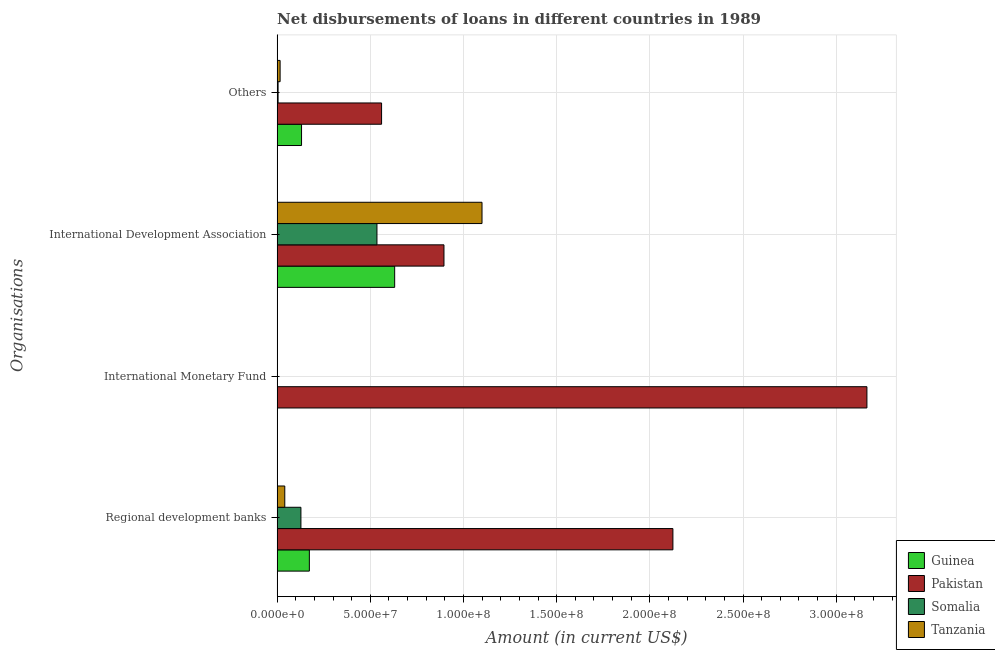How many bars are there on the 2nd tick from the top?
Offer a very short reply. 4. What is the label of the 2nd group of bars from the top?
Provide a short and direct response. International Development Association. What is the amount of loan disimbursed by regional development banks in Pakistan?
Your answer should be very brief. 2.12e+08. Across all countries, what is the maximum amount of loan disimbursed by regional development banks?
Give a very brief answer. 2.12e+08. Across all countries, what is the minimum amount of loan disimbursed by international development association?
Provide a short and direct response. 5.36e+07. In which country was the amount of loan disimbursed by regional development banks maximum?
Offer a very short reply. Pakistan. What is the total amount of loan disimbursed by international development association in the graph?
Make the answer very short. 3.16e+08. What is the difference between the amount of loan disimbursed by international development association in Guinea and that in Pakistan?
Your response must be concise. -2.65e+07. What is the difference between the amount of loan disimbursed by regional development banks in Guinea and the amount of loan disimbursed by international monetary fund in Somalia?
Provide a succinct answer. 1.73e+07. What is the average amount of loan disimbursed by other organisations per country?
Provide a succinct answer. 1.78e+07. What is the difference between the amount of loan disimbursed by regional development banks and amount of loan disimbursed by other organisations in Pakistan?
Offer a terse response. 1.56e+08. In how many countries, is the amount of loan disimbursed by international monetary fund greater than 230000000 US$?
Give a very brief answer. 1. What is the ratio of the amount of loan disimbursed by regional development banks in Tanzania to that in Somalia?
Ensure brevity in your answer.  0.32. Is the amount of loan disimbursed by regional development banks in Somalia less than that in Guinea?
Offer a very short reply. Yes. What is the difference between the highest and the lowest amount of loan disimbursed by regional development banks?
Offer a terse response. 2.08e+08. Is it the case that in every country, the sum of the amount of loan disimbursed by international monetary fund and amount of loan disimbursed by other organisations is greater than the sum of amount of loan disimbursed by international development association and amount of loan disimbursed by regional development banks?
Give a very brief answer. No. How many bars are there?
Your response must be concise. 13. Are all the bars in the graph horizontal?
Your answer should be compact. Yes. How many countries are there in the graph?
Give a very brief answer. 4. Does the graph contain grids?
Your answer should be compact. Yes. Where does the legend appear in the graph?
Provide a succinct answer. Bottom right. What is the title of the graph?
Your answer should be compact. Net disbursements of loans in different countries in 1989. What is the label or title of the Y-axis?
Your answer should be compact. Organisations. What is the Amount (in current US$) of Guinea in Regional development banks?
Make the answer very short. 1.73e+07. What is the Amount (in current US$) of Pakistan in Regional development banks?
Your answer should be very brief. 2.12e+08. What is the Amount (in current US$) of Somalia in Regional development banks?
Your response must be concise. 1.28e+07. What is the Amount (in current US$) in Tanzania in Regional development banks?
Your response must be concise. 4.11e+06. What is the Amount (in current US$) of Pakistan in International Monetary Fund?
Ensure brevity in your answer.  3.16e+08. What is the Amount (in current US$) of Tanzania in International Monetary Fund?
Your answer should be very brief. 0. What is the Amount (in current US$) of Guinea in International Development Association?
Your answer should be very brief. 6.31e+07. What is the Amount (in current US$) in Pakistan in International Development Association?
Your response must be concise. 8.95e+07. What is the Amount (in current US$) of Somalia in International Development Association?
Make the answer very short. 5.36e+07. What is the Amount (in current US$) in Tanzania in International Development Association?
Your response must be concise. 1.10e+08. What is the Amount (in current US$) of Guinea in Others?
Keep it short and to the point. 1.31e+07. What is the Amount (in current US$) of Pakistan in Others?
Provide a short and direct response. 5.60e+07. What is the Amount (in current US$) of Somalia in Others?
Offer a very short reply. 5.13e+05. What is the Amount (in current US$) in Tanzania in Others?
Your response must be concise. 1.60e+06. Across all Organisations, what is the maximum Amount (in current US$) in Guinea?
Provide a succinct answer. 6.31e+07. Across all Organisations, what is the maximum Amount (in current US$) of Pakistan?
Your answer should be very brief. 3.16e+08. Across all Organisations, what is the maximum Amount (in current US$) in Somalia?
Offer a very short reply. 5.36e+07. Across all Organisations, what is the maximum Amount (in current US$) of Tanzania?
Provide a short and direct response. 1.10e+08. Across all Organisations, what is the minimum Amount (in current US$) of Guinea?
Offer a terse response. 0. Across all Organisations, what is the minimum Amount (in current US$) of Pakistan?
Your answer should be compact. 5.60e+07. What is the total Amount (in current US$) in Guinea in the graph?
Give a very brief answer. 9.35e+07. What is the total Amount (in current US$) of Pakistan in the graph?
Provide a short and direct response. 6.74e+08. What is the total Amount (in current US$) of Somalia in the graph?
Provide a succinct answer. 6.68e+07. What is the total Amount (in current US$) in Tanzania in the graph?
Make the answer very short. 1.16e+08. What is the difference between the Amount (in current US$) in Pakistan in Regional development banks and that in International Monetary Fund?
Make the answer very short. -1.04e+08. What is the difference between the Amount (in current US$) in Guinea in Regional development banks and that in International Development Association?
Your answer should be very brief. -4.58e+07. What is the difference between the Amount (in current US$) of Pakistan in Regional development banks and that in International Development Association?
Give a very brief answer. 1.23e+08. What is the difference between the Amount (in current US$) in Somalia in Regional development banks and that in International Development Association?
Provide a short and direct response. -4.08e+07. What is the difference between the Amount (in current US$) in Tanzania in Regional development banks and that in International Development Association?
Your answer should be very brief. -1.06e+08. What is the difference between the Amount (in current US$) in Guinea in Regional development banks and that in Others?
Keep it short and to the point. 4.19e+06. What is the difference between the Amount (in current US$) in Pakistan in Regional development banks and that in Others?
Provide a short and direct response. 1.56e+08. What is the difference between the Amount (in current US$) in Somalia in Regional development banks and that in Others?
Ensure brevity in your answer.  1.23e+07. What is the difference between the Amount (in current US$) of Tanzania in Regional development banks and that in Others?
Your answer should be very brief. 2.51e+06. What is the difference between the Amount (in current US$) in Pakistan in International Monetary Fund and that in International Development Association?
Make the answer very short. 2.27e+08. What is the difference between the Amount (in current US$) of Pakistan in International Monetary Fund and that in Others?
Ensure brevity in your answer.  2.60e+08. What is the difference between the Amount (in current US$) of Guinea in International Development Association and that in Others?
Your answer should be very brief. 5.00e+07. What is the difference between the Amount (in current US$) in Pakistan in International Development Association and that in Others?
Offer a terse response. 3.35e+07. What is the difference between the Amount (in current US$) in Somalia in International Development Association and that in Others?
Your answer should be compact. 5.31e+07. What is the difference between the Amount (in current US$) in Tanzania in International Development Association and that in Others?
Your answer should be very brief. 1.08e+08. What is the difference between the Amount (in current US$) of Guinea in Regional development banks and the Amount (in current US$) of Pakistan in International Monetary Fund?
Keep it short and to the point. -2.99e+08. What is the difference between the Amount (in current US$) in Guinea in Regional development banks and the Amount (in current US$) in Pakistan in International Development Association?
Provide a succinct answer. -7.22e+07. What is the difference between the Amount (in current US$) of Guinea in Regional development banks and the Amount (in current US$) of Somalia in International Development Association?
Ensure brevity in your answer.  -3.63e+07. What is the difference between the Amount (in current US$) of Guinea in Regional development banks and the Amount (in current US$) of Tanzania in International Development Association?
Make the answer very short. -9.26e+07. What is the difference between the Amount (in current US$) in Pakistan in Regional development banks and the Amount (in current US$) in Somalia in International Development Association?
Offer a very short reply. 1.59e+08. What is the difference between the Amount (in current US$) in Pakistan in Regional development banks and the Amount (in current US$) in Tanzania in International Development Association?
Ensure brevity in your answer.  1.02e+08. What is the difference between the Amount (in current US$) of Somalia in Regional development banks and the Amount (in current US$) of Tanzania in International Development Association?
Offer a terse response. -9.72e+07. What is the difference between the Amount (in current US$) in Guinea in Regional development banks and the Amount (in current US$) in Pakistan in Others?
Offer a terse response. -3.88e+07. What is the difference between the Amount (in current US$) in Guinea in Regional development banks and the Amount (in current US$) in Somalia in Others?
Offer a terse response. 1.68e+07. What is the difference between the Amount (in current US$) in Guinea in Regional development banks and the Amount (in current US$) in Tanzania in Others?
Your answer should be very brief. 1.57e+07. What is the difference between the Amount (in current US$) of Pakistan in Regional development banks and the Amount (in current US$) of Somalia in Others?
Your answer should be very brief. 2.12e+08. What is the difference between the Amount (in current US$) in Pakistan in Regional development banks and the Amount (in current US$) in Tanzania in Others?
Offer a terse response. 2.11e+08. What is the difference between the Amount (in current US$) of Somalia in Regional development banks and the Amount (in current US$) of Tanzania in Others?
Give a very brief answer. 1.12e+07. What is the difference between the Amount (in current US$) in Pakistan in International Monetary Fund and the Amount (in current US$) in Somalia in International Development Association?
Your response must be concise. 2.63e+08. What is the difference between the Amount (in current US$) in Pakistan in International Monetary Fund and the Amount (in current US$) in Tanzania in International Development Association?
Keep it short and to the point. 2.07e+08. What is the difference between the Amount (in current US$) of Pakistan in International Monetary Fund and the Amount (in current US$) of Somalia in Others?
Offer a very short reply. 3.16e+08. What is the difference between the Amount (in current US$) of Pakistan in International Monetary Fund and the Amount (in current US$) of Tanzania in Others?
Make the answer very short. 3.15e+08. What is the difference between the Amount (in current US$) in Guinea in International Development Association and the Amount (in current US$) in Pakistan in Others?
Offer a terse response. 7.02e+06. What is the difference between the Amount (in current US$) of Guinea in International Development Association and the Amount (in current US$) of Somalia in Others?
Ensure brevity in your answer.  6.26e+07. What is the difference between the Amount (in current US$) in Guinea in International Development Association and the Amount (in current US$) in Tanzania in Others?
Ensure brevity in your answer.  6.15e+07. What is the difference between the Amount (in current US$) of Pakistan in International Development Association and the Amount (in current US$) of Somalia in Others?
Provide a succinct answer. 8.90e+07. What is the difference between the Amount (in current US$) of Pakistan in International Development Association and the Amount (in current US$) of Tanzania in Others?
Your answer should be compact. 8.79e+07. What is the difference between the Amount (in current US$) in Somalia in International Development Association and the Amount (in current US$) in Tanzania in Others?
Your answer should be very brief. 5.20e+07. What is the average Amount (in current US$) of Guinea per Organisations?
Keep it short and to the point. 2.34e+07. What is the average Amount (in current US$) of Pakistan per Organisations?
Your answer should be compact. 1.69e+08. What is the average Amount (in current US$) of Somalia per Organisations?
Provide a succinct answer. 1.67e+07. What is the average Amount (in current US$) of Tanzania per Organisations?
Provide a short and direct response. 2.89e+07. What is the difference between the Amount (in current US$) in Guinea and Amount (in current US$) in Pakistan in Regional development banks?
Your answer should be very brief. -1.95e+08. What is the difference between the Amount (in current US$) of Guinea and Amount (in current US$) of Somalia in Regional development banks?
Your answer should be compact. 4.52e+06. What is the difference between the Amount (in current US$) of Guinea and Amount (in current US$) of Tanzania in Regional development banks?
Your answer should be compact. 1.32e+07. What is the difference between the Amount (in current US$) in Pakistan and Amount (in current US$) in Somalia in Regional development banks?
Keep it short and to the point. 2.00e+08. What is the difference between the Amount (in current US$) in Pakistan and Amount (in current US$) in Tanzania in Regional development banks?
Offer a very short reply. 2.08e+08. What is the difference between the Amount (in current US$) of Somalia and Amount (in current US$) of Tanzania in Regional development banks?
Give a very brief answer. 8.66e+06. What is the difference between the Amount (in current US$) of Guinea and Amount (in current US$) of Pakistan in International Development Association?
Make the answer very short. -2.65e+07. What is the difference between the Amount (in current US$) of Guinea and Amount (in current US$) of Somalia in International Development Association?
Your answer should be compact. 9.51e+06. What is the difference between the Amount (in current US$) of Guinea and Amount (in current US$) of Tanzania in International Development Association?
Offer a terse response. -4.69e+07. What is the difference between the Amount (in current US$) of Pakistan and Amount (in current US$) of Somalia in International Development Association?
Make the answer very short. 3.60e+07. What is the difference between the Amount (in current US$) of Pakistan and Amount (in current US$) of Tanzania in International Development Association?
Your response must be concise. -2.04e+07. What is the difference between the Amount (in current US$) in Somalia and Amount (in current US$) in Tanzania in International Development Association?
Your answer should be very brief. -5.64e+07. What is the difference between the Amount (in current US$) of Guinea and Amount (in current US$) of Pakistan in Others?
Your response must be concise. -4.29e+07. What is the difference between the Amount (in current US$) in Guinea and Amount (in current US$) in Somalia in Others?
Provide a succinct answer. 1.26e+07. What is the difference between the Amount (in current US$) in Guinea and Amount (in current US$) in Tanzania in Others?
Your answer should be very brief. 1.15e+07. What is the difference between the Amount (in current US$) in Pakistan and Amount (in current US$) in Somalia in Others?
Provide a succinct answer. 5.55e+07. What is the difference between the Amount (in current US$) of Pakistan and Amount (in current US$) of Tanzania in Others?
Ensure brevity in your answer.  5.44e+07. What is the difference between the Amount (in current US$) in Somalia and Amount (in current US$) in Tanzania in Others?
Your answer should be compact. -1.09e+06. What is the ratio of the Amount (in current US$) in Pakistan in Regional development banks to that in International Monetary Fund?
Give a very brief answer. 0.67. What is the ratio of the Amount (in current US$) in Guinea in Regional development banks to that in International Development Association?
Offer a very short reply. 0.27. What is the ratio of the Amount (in current US$) of Pakistan in Regional development banks to that in International Development Association?
Offer a very short reply. 2.37. What is the ratio of the Amount (in current US$) in Somalia in Regional development banks to that in International Development Association?
Give a very brief answer. 0.24. What is the ratio of the Amount (in current US$) of Tanzania in Regional development banks to that in International Development Association?
Your answer should be compact. 0.04. What is the ratio of the Amount (in current US$) of Guinea in Regional development banks to that in Others?
Your answer should be very brief. 1.32. What is the ratio of the Amount (in current US$) of Pakistan in Regional development banks to that in Others?
Your answer should be compact. 3.79. What is the ratio of the Amount (in current US$) in Somalia in Regional development banks to that in Others?
Offer a terse response. 24.89. What is the ratio of the Amount (in current US$) of Tanzania in Regional development banks to that in Others?
Your answer should be compact. 2.56. What is the ratio of the Amount (in current US$) in Pakistan in International Monetary Fund to that in International Development Association?
Give a very brief answer. 3.53. What is the ratio of the Amount (in current US$) of Pakistan in International Monetary Fund to that in Others?
Your answer should be compact. 5.65. What is the ratio of the Amount (in current US$) of Guinea in International Development Association to that in Others?
Your answer should be compact. 4.81. What is the ratio of the Amount (in current US$) in Pakistan in International Development Association to that in Others?
Offer a very short reply. 1.6. What is the ratio of the Amount (in current US$) of Somalia in International Development Association to that in Others?
Give a very brief answer. 104.41. What is the ratio of the Amount (in current US$) in Tanzania in International Development Association to that in Others?
Give a very brief answer. 68.54. What is the difference between the highest and the second highest Amount (in current US$) of Guinea?
Give a very brief answer. 4.58e+07. What is the difference between the highest and the second highest Amount (in current US$) of Pakistan?
Provide a succinct answer. 1.04e+08. What is the difference between the highest and the second highest Amount (in current US$) in Somalia?
Provide a short and direct response. 4.08e+07. What is the difference between the highest and the second highest Amount (in current US$) of Tanzania?
Offer a very short reply. 1.06e+08. What is the difference between the highest and the lowest Amount (in current US$) in Guinea?
Provide a short and direct response. 6.31e+07. What is the difference between the highest and the lowest Amount (in current US$) of Pakistan?
Provide a short and direct response. 2.60e+08. What is the difference between the highest and the lowest Amount (in current US$) in Somalia?
Provide a short and direct response. 5.36e+07. What is the difference between the highest and the lowest Amount (in current US$) of Tanzania?
Give a very brief answer. 1.10e+08. 